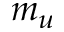<formula> <loc_0><loc_0><loc_500><loc_500>m _ { u }</formula> 